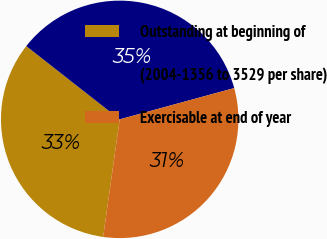<chart> <loc_0><loc_0><loc_500><loc_500><pie_chart><fcel>Outstanding at beginning of<fcel>(2004-1356 to 3529 per share)<fcel>Exercisable at end of year<nl><fcel>33.36%<fcel>35.17%<fcel>31.47%<nl></chart> 